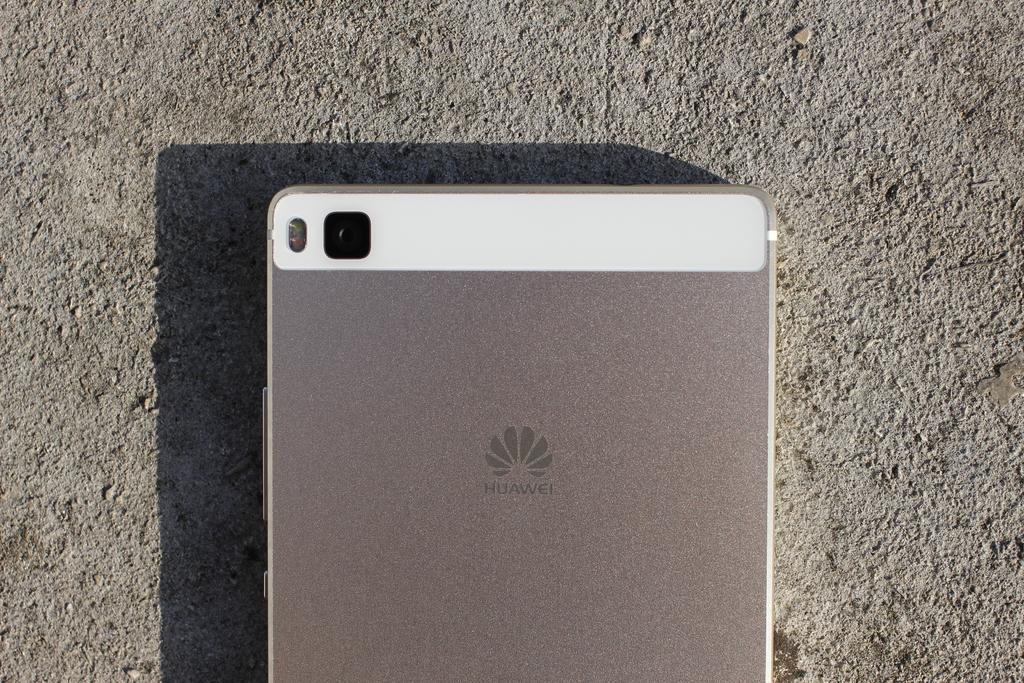What brand of phone is this?
Your answer should be compact. Huawei. 